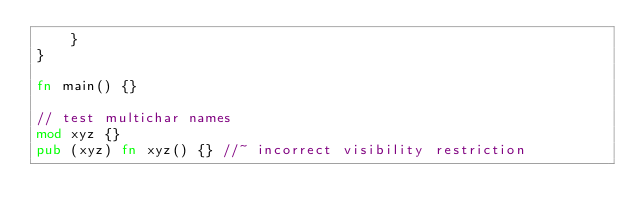Convert code to text. <code><loc_0><loc_0><loc_500><loc_500><_Rust_>    }
}

fn main() {}

// test multichar names
mod xyz {}
pub (xyz) fn xyz() {} //~ incorrect visibility restriction
</code> 